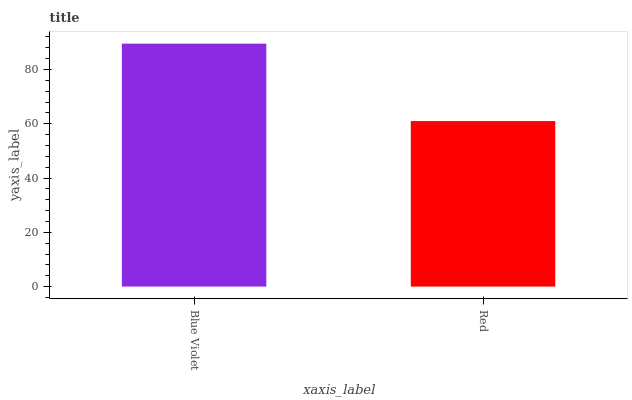Is Red the minimum?
Answer yes or no. Yes. Is Blue Violet the maximum?
Answer yes or no. Yes. Is Red the maximum?
Answer yes or no. No. Is Blue Violet greater than Red?
Answer yes or no. Yes. Is Red less than Blue Violet?
Answer yes or no. Yes. Is Red greater than Blue Violet?
Answer yes or no. No. Is Blue Violet less than Red?
Answer yes or no. No. Is Blue Violet the high median?
Answer yes or no. Yes. Is Red the low median?
Answer yes or no. Yes. Is Red the high median?
Answer yes or no. No. Is Blue Violet the low median?
Answer yes or no. No. 